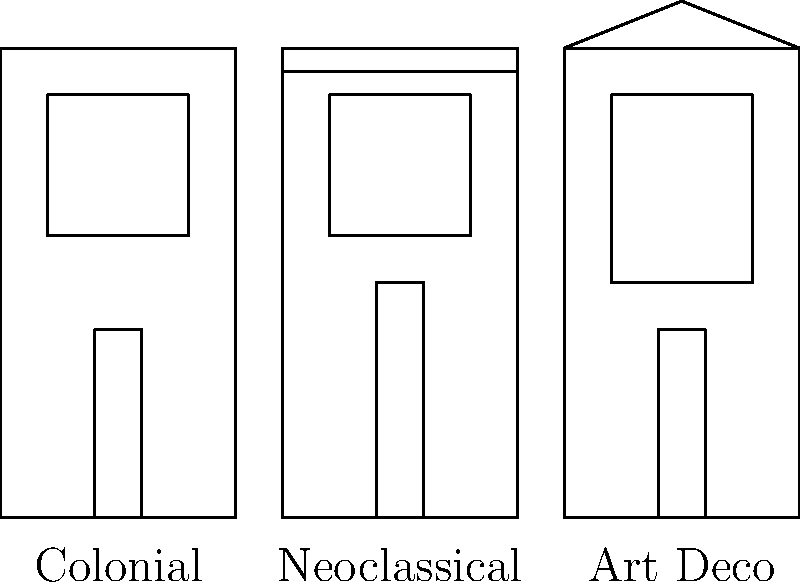Based on the simplified facade diagrams representing the architectural evolution of Havana's historic buildings, which style is characterized by a triangular pediment and geometric patterns? To answer this question, let's analyze the three architectural styles presented in the diagram:

1. Colonial style (16th-18th century):
   - Simple rectangular shape
   - Large window on the upper floor
   - Narrow door on the ground floor
   - No distinctive roof features

2. Neoclassical style (19th century):
   - Rectangular shape similar to Colonial
   - Large window on the upper floor
   - Taller door on the ground floor
   - Notable cornice at the top of the facade

3. Art Deco style (early 20th century):
   - Rectangular shape with more pronounced vertical emphasis
   - Large window with geometric patterns
   - Narrow door on the ground floor
   - Distinctive triangular pediment at the top of the facade

The question asks about a style characterized by a triangular pediment and geometric patterns. Looking at the diagram, we can see that only the Art Deco style features a triangular pediment at the top of the facade. Additionally, Art Deco is known for its geometric patterns, which are suggested by the shape of the window in this simplified diagram.

Therefore, the architectural style that matches the description in the question is Art Deco.
Answer: Art Deco 